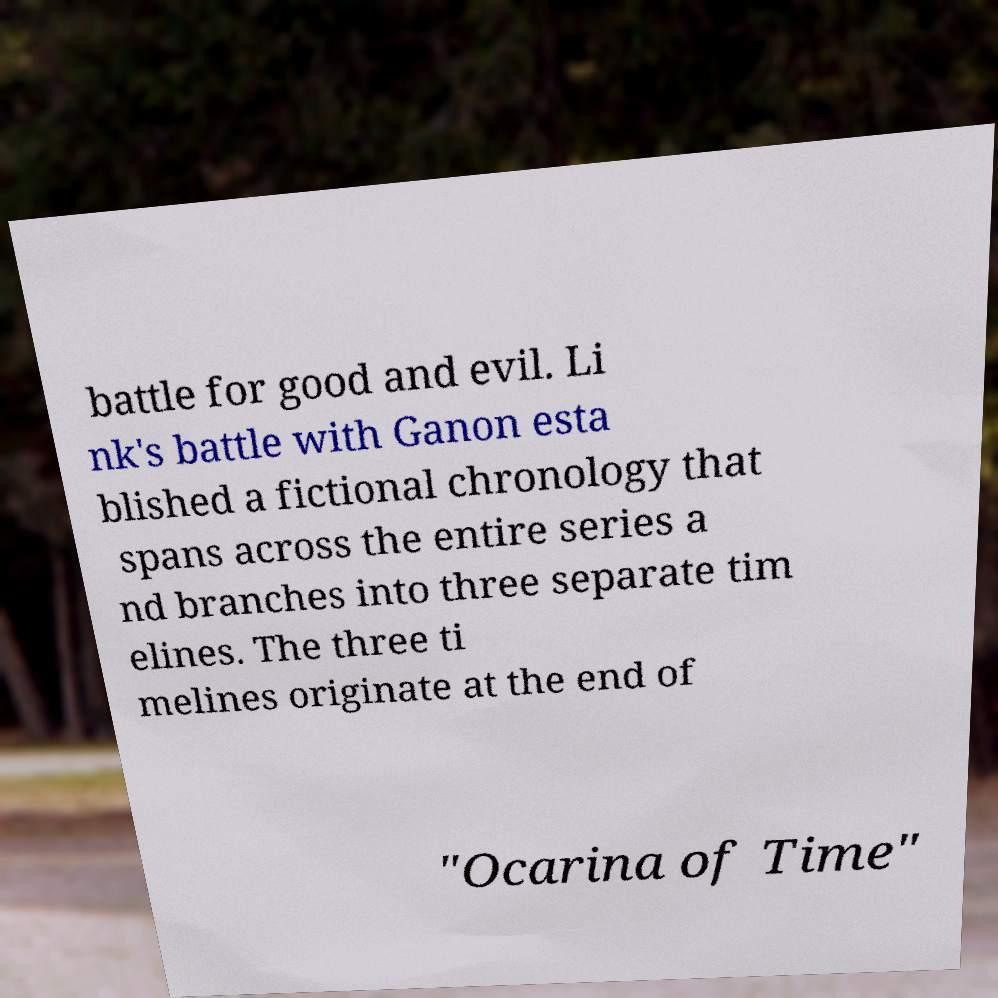Can you read and provide the text displayed in the image?This photo seems to have some interesting text. Can you extract and type it out for me? battle for good and evil. Li nk's battle with Ganon esta blished a fictional chronology that spans across the entire series a nd branches into three separate tim elines. The three ti melines originate at the end of "Ocarina of Time" 